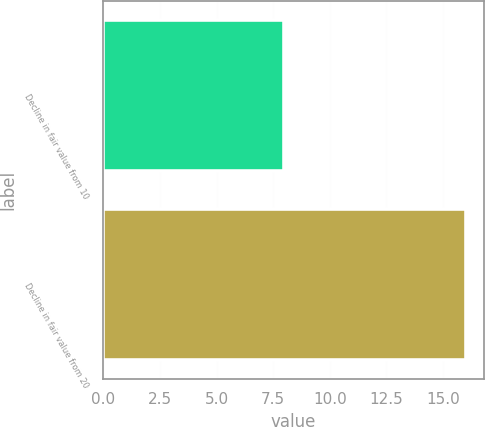Convert chart to OTSL. <chart><loc_0><loc_0><loc_500><loc_500><bar_chart><fcel>Decline in fair value from 10<fcel>Decline in fair value from 20<nl><fcel>8<fcel>16<nl></chart> 